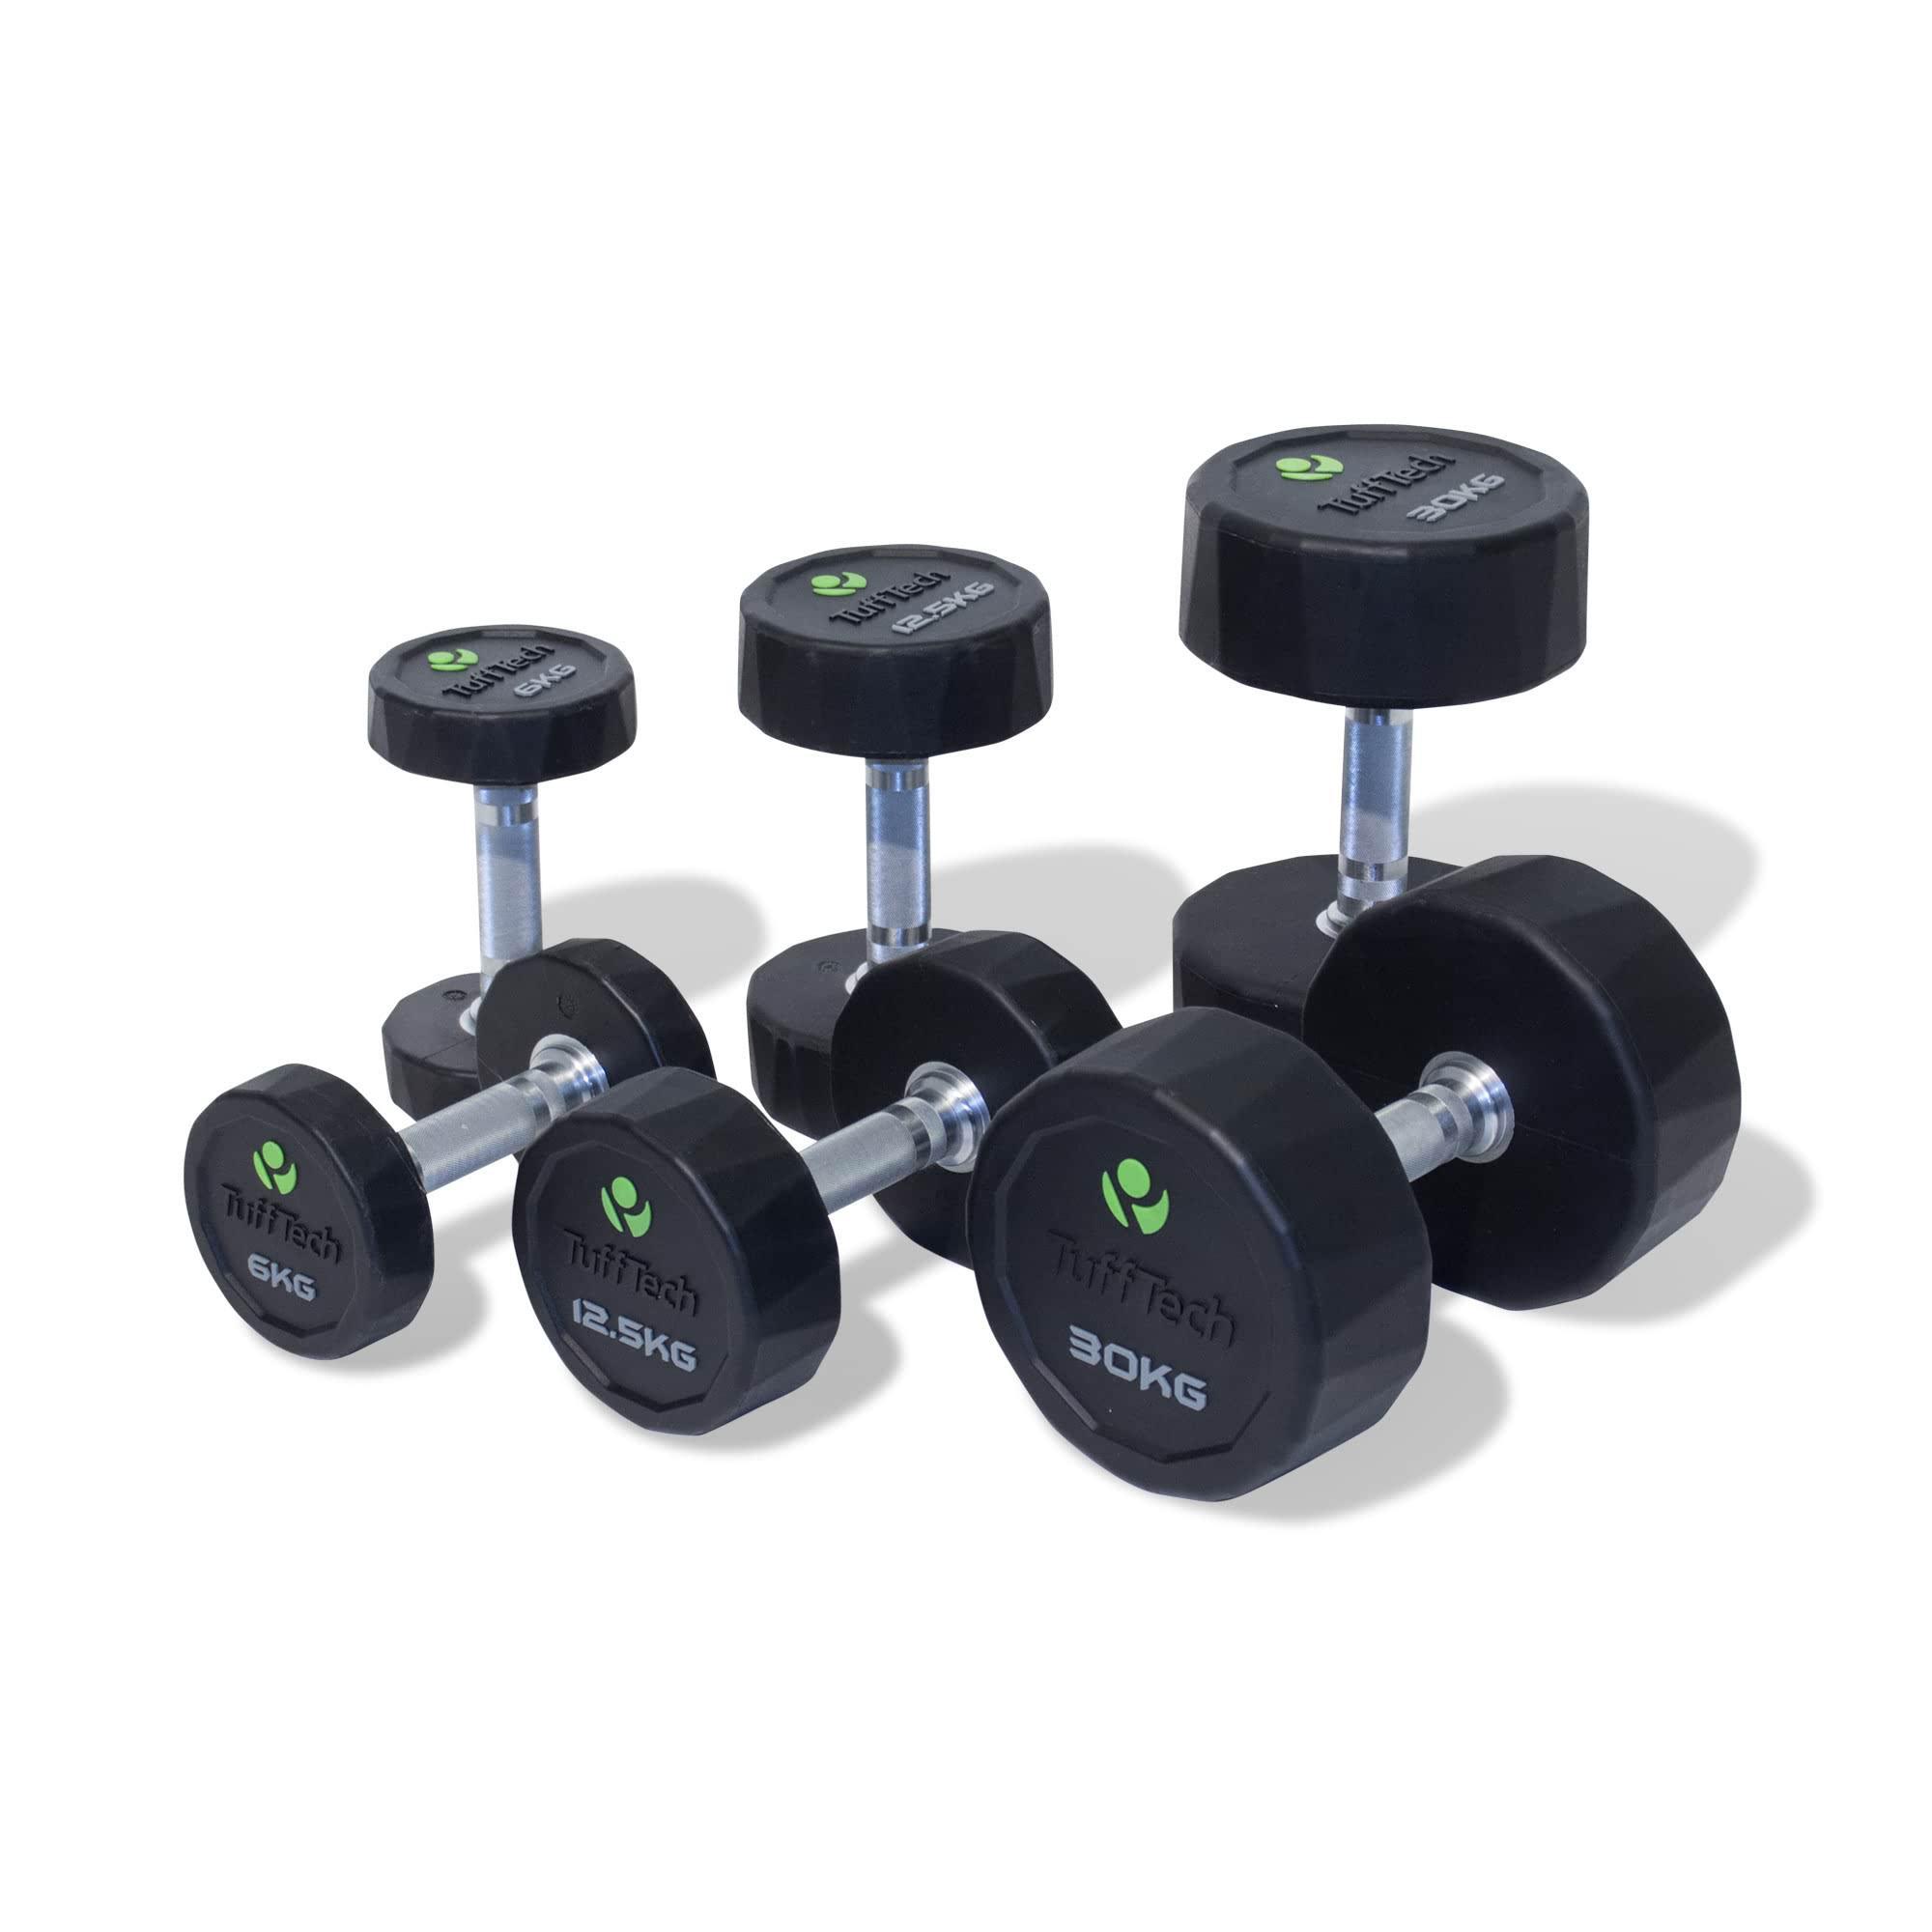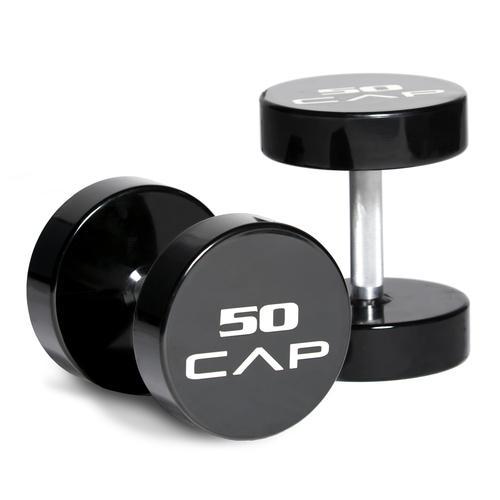The first image is the image on the left, the second image is the image on the right. Examine the images to the left and right. Is the description "The left image shows at least three black barbells." accurate? Answer yes or no. Yes. The first image is the image on the left, the second image is the image on the right. For the images displayed, is the sentence "There are more dumbbells in the right image than in the left image." factually correct? Answer yes or no. No. 